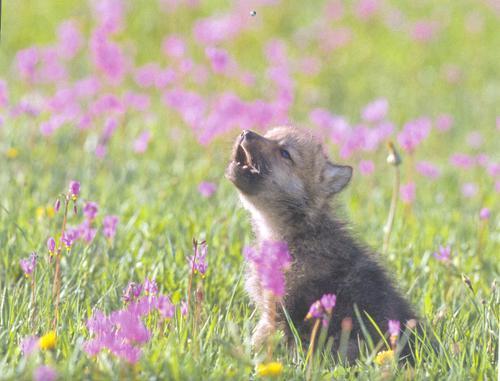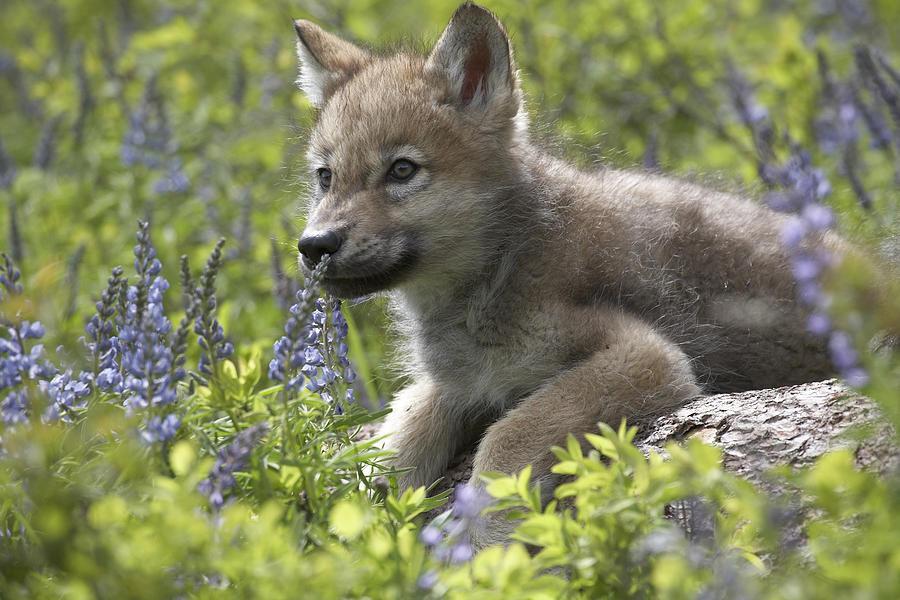The first image is the image on the left, the second image is the image on the right. For the images displayed, is the sentence "There is at least three wolves." factually correct? Answer yes or no. No. 